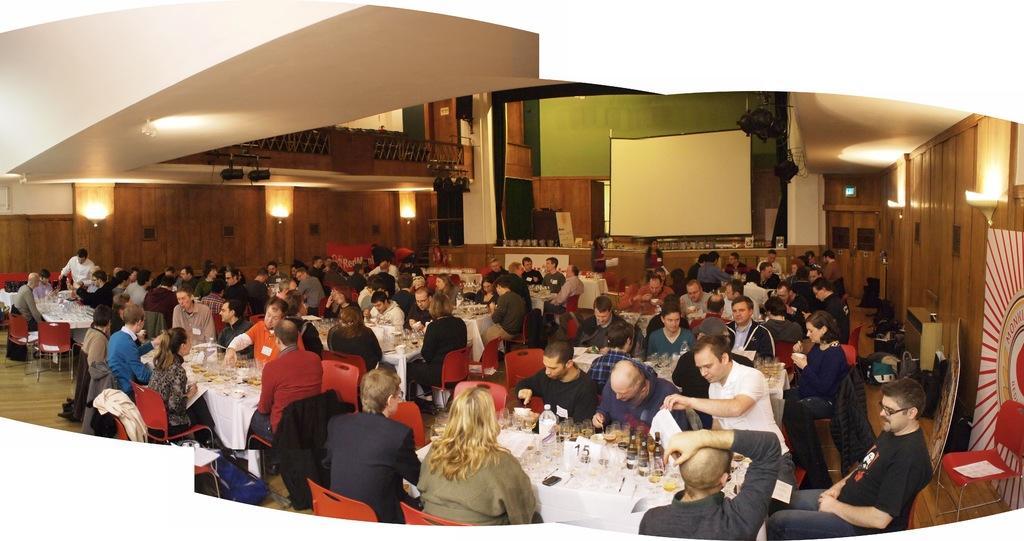Describe this image in one or two sentences. In this image I can see a group of people are sitting on a chair in front of a table. On the table we have a couple of objects on it. I can also see there is a projector screen. 